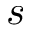Convert formula to latex. <formula><loc_0><loc_0><loc_500><loc_500>s</formula> 